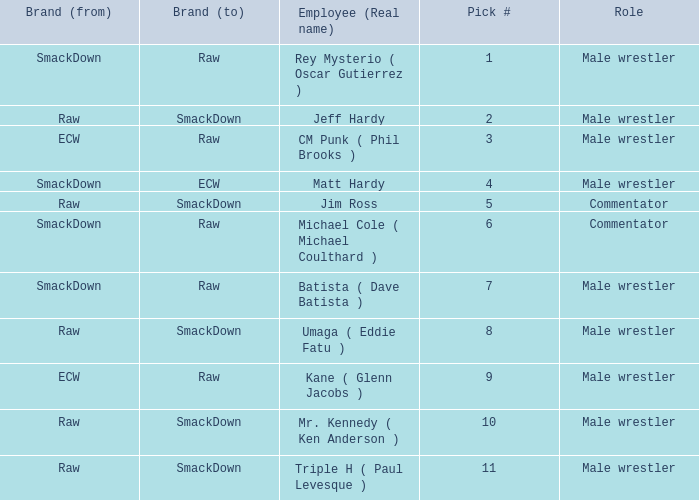What is the real name of the Pick # that is greater than 9? Mr. Kennedy ( Ken Anderson ), Triple H ( Paul Levesque ). 